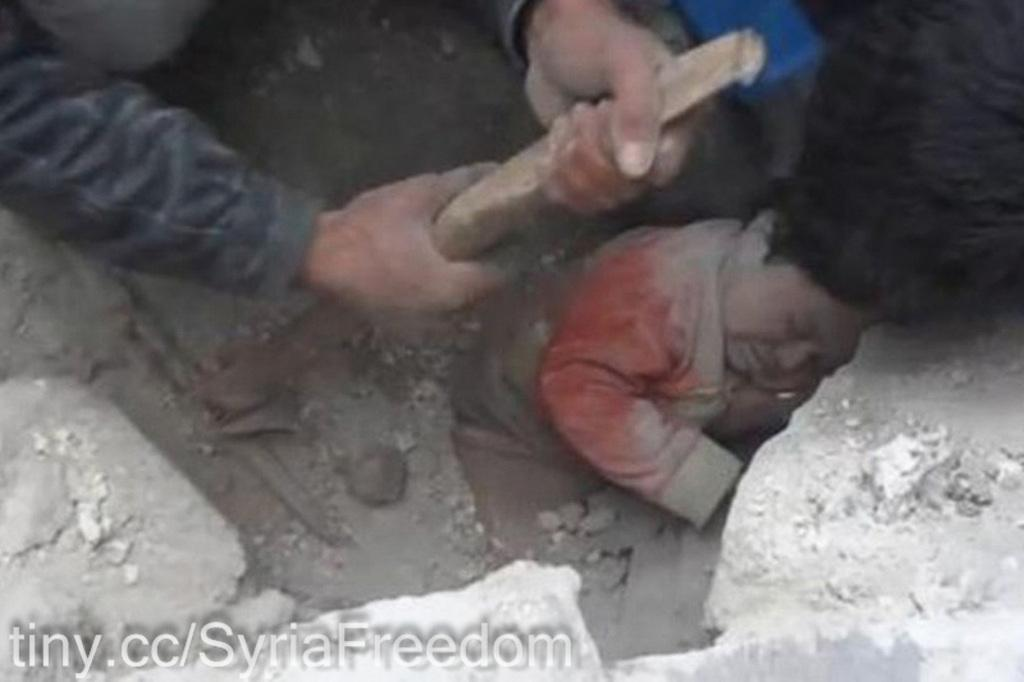What is at the bottom of the image? There are stones at the bottom of the image. What is on the stones? A kid is visible on the stones. What is happening at the top of the image? There is a person sitting at the top of the image. What is the person holding? The person is holding a hammer. What type of structure is visible in the dust in the image? There is no dust or structure present in the image. How does the society depicted in the image react to the person holding the hammer? There is no society depicted in the image, only a person holding a hammer and a kid on the stones. 